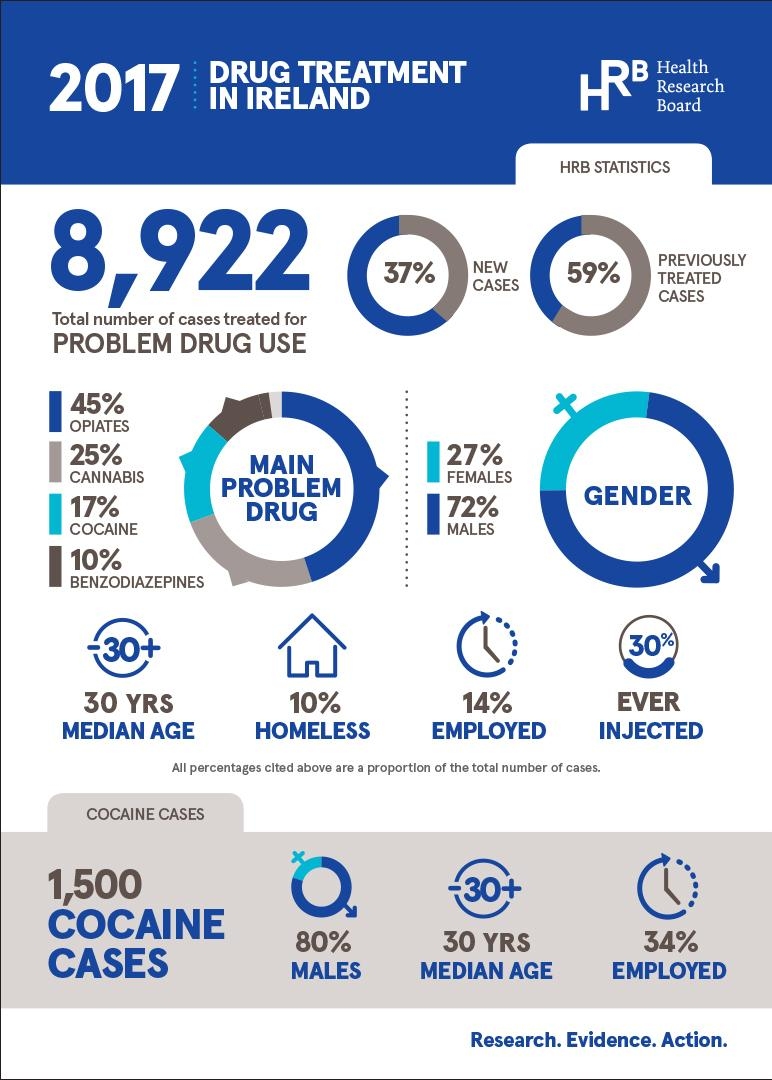Identify some key points in this picture. Approximately 10% of all drug cases involve individuals who are homeless. The median age of individuals using cocaine is 30 years old, according to recent data. According to data, 34% of individuals involved in cocaine-related cases are employed. Approximately one in four individuals who use cannabis require drug treatment, according to recent statistics. A majority of individuals receiving treatment for drug use are males. 